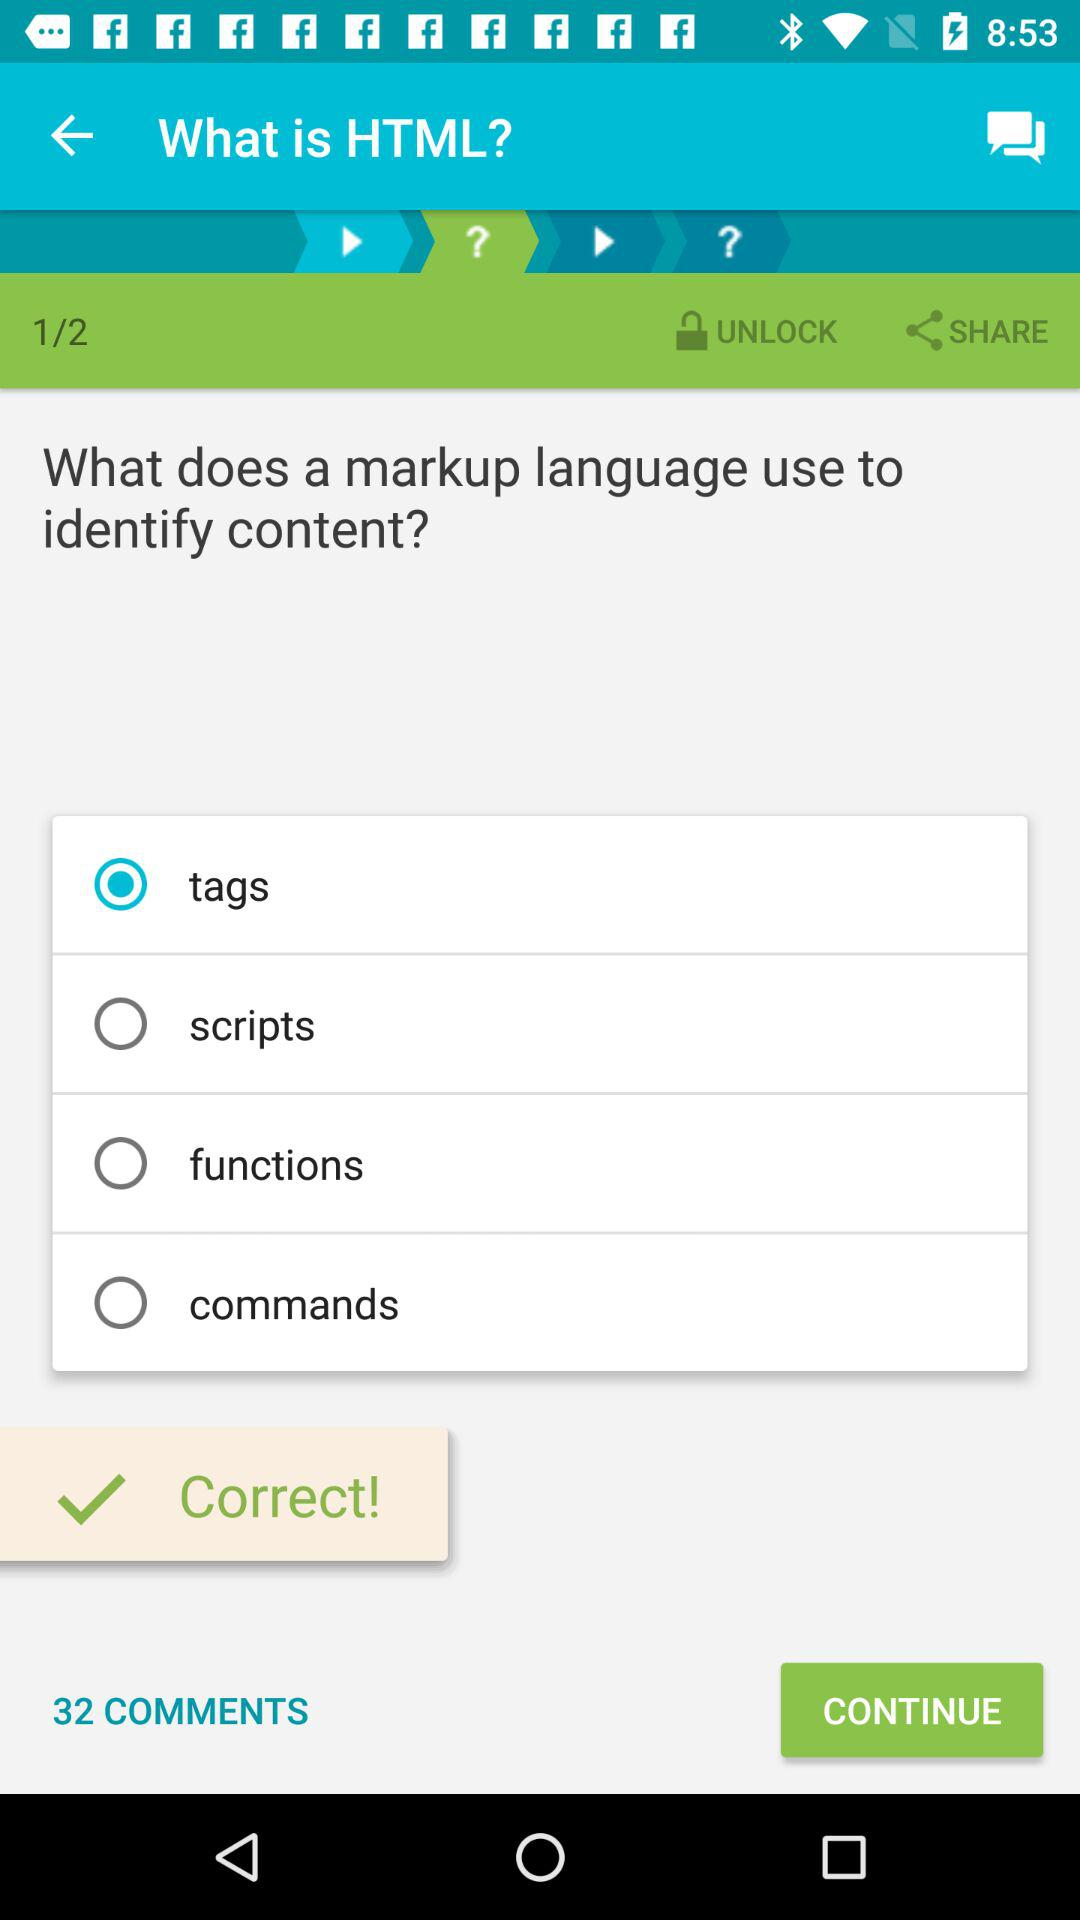Is the user correct or incorrect? The user is correct. 